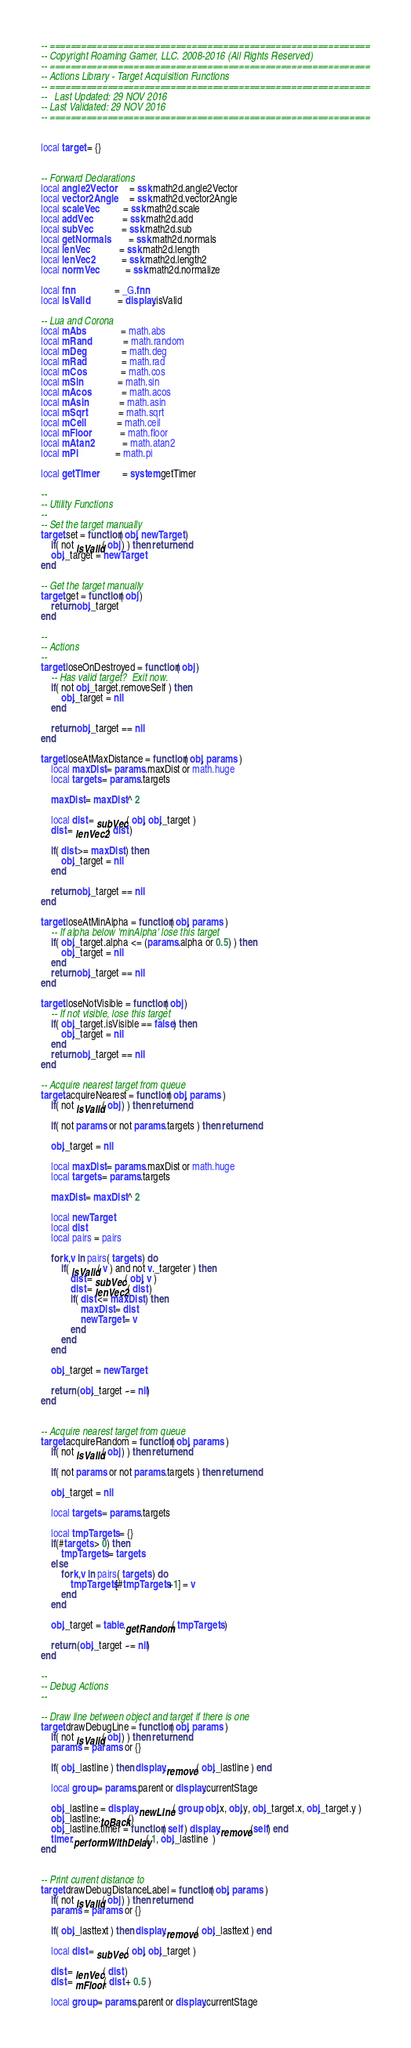<code> <loc_0><loc_0><loc_500><loc_500><_Lua_>-- =============================================================
-- Copyright Roaming Gamer, LLC. 2008-2016 (All Rights Reserved)
-- =============================================================
-- Actions Library - Target Acquisition Functions
-- =============================================================
--   Last Updated: 29 NOV 2016
-- Last Validated: 29 NOV 2016
-- =============================================================


local target = {}


-- Forward Declarations
local angle2Vector      = ssk.math2d.angle2Vector
local vector2Angle      = ssk.math2d.vector2Angle
local scaleVec          = ssk.math2d.scale
local addVec            = ssk.math2d.add
local subVec            = ssk.math2d.sub
local getNormals        = ssk.math2d.normals
local lenVec            = ssk.math2d.length
local lenVec2           = ssk.math2d.length2
local normVec           = ssk.math2d.normalize

local fnn 				= _G.fnn
local isValid 			= display.isValid

-- Lua and Corona
local mAbs              = math.abs
local mRand             = math.random
local mDeg              = math.deg
local mRad              = math.rad
local mCos              = math.cos
local mSin              = math.sin
local mAcos             = math.acos
local mAsin             = math.asin
local mSqrt             = math.sqrt
local mCeil             = math.ceil
local mFloor            = math.floor
local mAtan2            = math.atan2
local mPi               = math.pi

local getTimer          = system.getTimer

--
-- Utility Functions
--
-- Set the target manually
target.set = function( obj, newTarget )
	if( not isValid( obj ) ) then return end
	obj._target = newTarget
end

-- Get the target manually
target.get = function( obj )	
	return obj._target
end

--
-- Actions 
--
target.loseOnDestroyed = function( obj )
	-- Has valid target?  Exit now.
	if( not obj._target.removeSelf ) then 
		obj._target = nil		
	end

	return obj._target == nil
end	

target.loseAtMaxDistance = function( obj, params )
	local maxDist = params.maxDist or math.huge
	local targets = params.targets

	maxDist = maxDist ^ 2

	local dist = subVec( obj, obj._target )
	dist = lenVec2( dist )

	if( dist >= maxDist ) then 
		obj._target = nil
	end

	return obj._target == nil
end

target.loseAtMinAlpha = function( obj, params )
	-- If alpha below 'minAlpha' lose this target
	if( obj._target.alpha <= (params.alpha or 0.5) ) then 
		obj._target = nil
	end
	return obj._target == nil
end

target.loseNotVisible = function( obj )
	-- If not visible, lose this target
	if( obj._target.isVisible == false) then 
		obj._target = nil
	end
	return obj._target == nil
end

-- Acquire nearest target from queue
target.acquireNearest = function( obj, params )
	if( not isValid( obj ) ) then return end

	if( not params or not params.targets ) then return end

	obj._target = nil
	
	local maxDist = params.maxDist or math.huge
	local targets = params.targets

	maxDist = maxDist ^ 2

	local newTarget
	local dist
	local pairs = pairs
	
	for k,v in pairs( targets ) do
		if( isValid( v ) and not v._targeter ) then
			dist = subVec( obj, v )
			dist = lenVec2( dist )
			if( dist <= maxDist ) then
				maxDist = dist
				newTarget = v
			end
		end
	end

	obj._target = newTarget

	return (obj._target ~= nil)
end


-- Acquire nearest target from queue
target.acquireRandom = function( obj, params )
	if( not isValid( obj ) ) then return end

	if( not params or not params.targets ) then return end

	obj._target = nil
	
	local targets = params.targets

	local tmpTargets = {}
	if(#targets > 0) then
		tmpTargets = targets
	else
		for k,v in pairs( targets ) do
			tmpTargets[#tmpTargets+1] = v 
		end
	end

	obj._target = table.getRandom( tmpTargets )

	return (obj._target ~= nil)
end

--
-- Debug Actions
--

-- Draw line between object and target if there is one
target.drawDebugLine = function( obj, params )
	if( not isValid( obj ) ) then return end
	params = params or {}

	if( obj._lastline ) then display.remove( obj._lastline ) end

	local group = params.parent or display.currentStage

	obj._lastline = display.newLine( group, obj.x, obj.y, obj._target.x, obj._target.y )
	obj._lastline:toBack()
	obj._lastline.timer = function( self ) display.remove(self) end 
	timer.performWithDelay( 1, obj._lastline  )
end


-- Print current distance to
target.drawDebugDistanceLabel = function( obj, params )
	if( not isValid( obj ) ) then return end
	params = params or {}

	if( obj._lasttext ) then display.remove( obj._lasttext ) end

	local dist = subVec( obj, obj._target )

	dist = lenVec( dist )
	dist = mFloor( dist + 0.5 )

	local group = params.parent or display.currentStage
</code> 